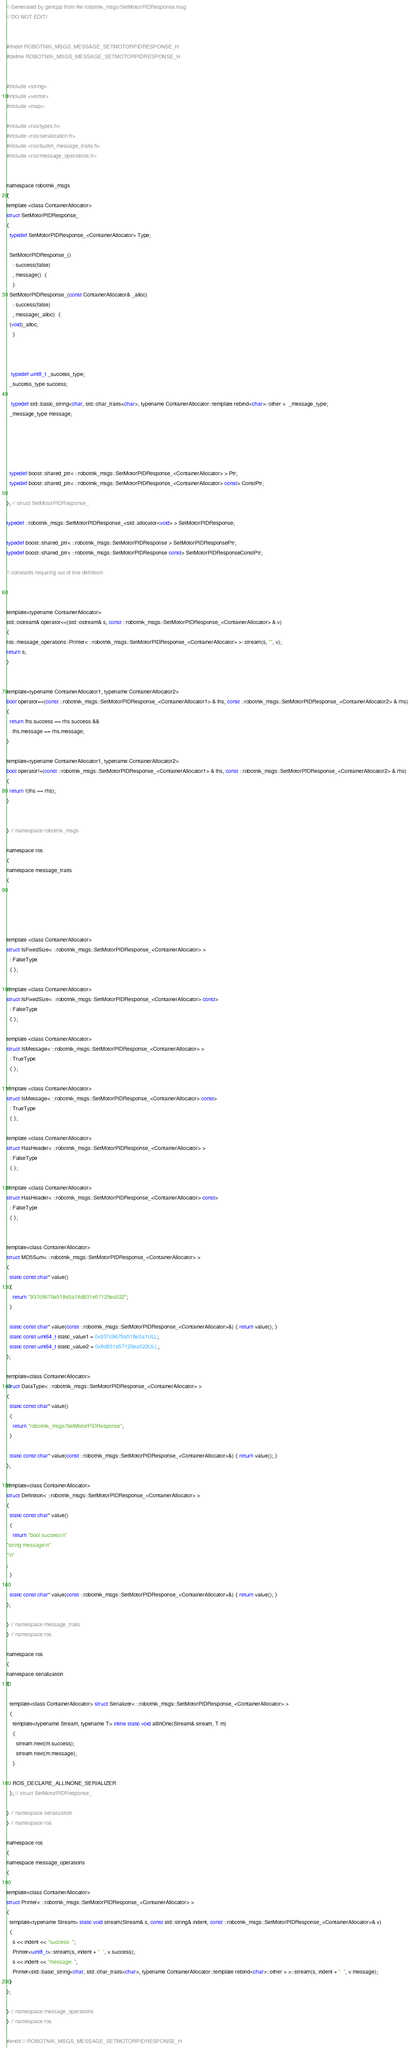Convert code to text. <code><loc_0><loc_0><loc_500><loc_500><_C_>// Generated by gencpp from file robotnik_msgs/SetMotorPIDResponse.msg
// DO NOT EDIT!


#ifndef ROBOTNIK_MSGS_MESSAGE_SETMOTORPIDRESPONSE_H
#define ROBOTNIK_MSGS_MESSAGE_SETMOTORPIDRESPONSE_H


#include <string>
#include <vector>
#include <map>

#include <ros/types.h>
#include <ros/serialization.h>
#include <ros/builtin_message_traits.h>
#include <ros/message_operations.h>


namespace robotnik_msgs
{
template <class ContainerAllocator>
struct SetMotorPIDResponse_
{
  typedef SetMotorPIDResponse_<ContainerAllocator> Type;

  SetMotorPIDResponse_()
    : success(false)
    , message()  {
    }
  SetMotorPIDResponse_(const ContainerAllocator& _alloc)
    : success(false)
    , message(_alloc)  {
  (void)_alloc;
    }



   typedef uint8_t _success_type;
  _success_type success;

   typedef std::basic_string<char, std::char_traits<char>, typename ContainerAllocator::template rebind<char>::other >  _message_type;
  _message_type message;





  typedef boost::shared_ptr< ::robotnik_msgs::SetMotorPIDResponse_<ContainerAllocator> > Ptr;
  typedef boost::shared_ptr< ::robotnik_msgs::SetMotorPIDResponse_<ContainerAllocator> const> ConstPtr;

}; // struct SetMotorPIDResponse_

typedef ::robotnik_msgs::SetMotorPIDResponse_<std::allocator<void> > SetMotorPIDResponse;

typedef boost::shared_ptr< ::robotnik_msgs::SetMotorPIDResponse > SetMotorPIDResponsePtr;
typedef boost::shared_ptr< ::robotnik_msgs::SetMotorPIDResponse const> SetMotorPIDResponseConstPtr;

// constants requiring out of line definition



template<typename ContainerAllocator>
std::ostream& operator<<(std::ostream& s, const ::robotnik_msgs::SetMotorPIDResponse_<ContainerAllocator> & v)
{
ros::message_operations::Printer< ::robotnik_msgs::SetMotorPIDResponse_<ContainerAllocator> >::stream(s, "", v);
return s;
}


template<typename ContainerAllocator1, typename ContainerAllocator2>
bool operator==(const ::robotnik_msgs::SetMotorPIDResponse_<ContainerAllocator1> & lhs, const ::robotnik_msgs::SetMotorPIDResponse_<ContainerAllocator2> & rhs)
{
  return lhs.success == rhs.success &&
    lhs.message == rhs.message;
}

template<typename ContainerAllocator1, typename ContainerAllocator2>
bool operator!=(const ::robotnik_msgs::SetMotorPIDResponse_<ContainerAllocator1> & lhs, const ::robotnik_msgs::SetMotorPIDResponse_<ContainerAllocator2> & rhs)
{
  return !(lhs == rhs);
}


} // namespace robotnik_msgs

namespace ros
{
namespace message_traits
{





template <class ContainerAllocator>
struct IsFixedSize< ::robotnik_msgs::SetMotorPIDResponse_<ContainerAllocator> >
  : FalseType
  { };

template <class ContainerAllocator>
struct IsFixedSize< ::robotnik_msgs::SetMotorPIDResponse_<ContainerAllocator> const>
  : FalseType
  { };

template <class ContainerAllocator>
struct IsMessage< ::robotnik_msgs::SetMotorPIDResponse_<ContainerAllocator> >
  : TrueType
  { };

template <class ContainerAllocator>
struct IsMessage< ::robotnik_msgs::SetMotorPIDResponse_<ContainerAllocator> const>
  : TrueType
  { };

template <class ContainerAllocator>
struct HasHeader< ::robotnik_msgs::SetMotorPIDResponse_<ContainerAllocator> >
  : FalseType
  { };

template <class ContainerAllocator>
struct HasHeader< ::robotnik_msgs::SetMotorPIDResponse_<ContainerAllocator> const>
  : FalseType
  { };


template<class ContainerAllocator>
struct MD5Sum< ::robotnik_msgs::SetMotorPIDResponse_<ContainerAllocator> >
{
  static const char* value()
  {
    return "937c9679a518e3a18d831e57125ea522";
  }

  static const char* value(const ::robotnik_msgs::SetMotorPIDResponse_<ContainerAllocator>&) { return value(); }
  static const uint64_t static_value1 = 0x937c9679a518e3a1ULL;
  static const uint64_t static_value2 = 0x8d831e57125ea522ULL;
};

template<class ContainerAllocator>
struct DataType< ::robotnik_msgs::SetMotorPIDResponse_<ContainerAllocator> >
{
  static const char* value()
  {
    return "robotnik_msgs/SetMotorPIDResponse";
  }

  static const char* value(const ::robotnik_msgs::SetMotorPIDResponse_<ContainerAllocator>&) { return value(); }
};

template<class ContainerAllocator>
struct Definition< ::robotnik_msgs::SetMotorPIDResponse_<ContainerAllocator> >
{
  static const char* value()
  {
    return "bool success\n"
"string message\n"
"\n"
;
  }

  static const char* value(const ::robotnik_msgs::SetMotorPIDResponse_<ContainerAllocator>&) { return value(); }
};

} // namespace message_traits
} // namespace ros

namespace ros
{
namespace serialization
{

  template<class ContainerAllocator> struct Serializer< ::robotnik_msgs::SetMotorPIDResponse_<ContainerAllocator> >
  {
    template<typename Stream, typename T> inline static void allInOne(Stream& stream, T m)
    {
      stream.next(m.success);
      stream.next(m.message);
    }

    ROS_DECLARE_ALLINONE_SERIALIZER
  }; // struct SetMotorPIDResponse_

} // namespace serialization
} // namespace ros

namespace ros
{
namespace message_operations
{

template<class ContainerAllocator>
struct Printer< ::robotnik_msgs::SetMotorPIDResponse_<ContainerAllocator> >
{
  template<typename Stream> static void stream(Stream& s, const std::string& indent, const ::robotnik_msgs::SetMotorPIDResponse_<ContainerAllocator>& v)
  {
    s << indent << "success: ";
    Printer<uint8_t>::stream(s, indent + "  ", v.success);
    s << indent << "message: ";
    Printer<std::basic_string<char, std::char_traits<char>, typename ContainerAllocator::template rebind<char>::other > >::stream(s, indent + "  ", v.message);
  }
};

} // namespace message_operations
} // namespace ros

#endif // ROBOTNIK_MSGS_MESSAGE_SETMOTORPIDRESPONSE_H
</code> 